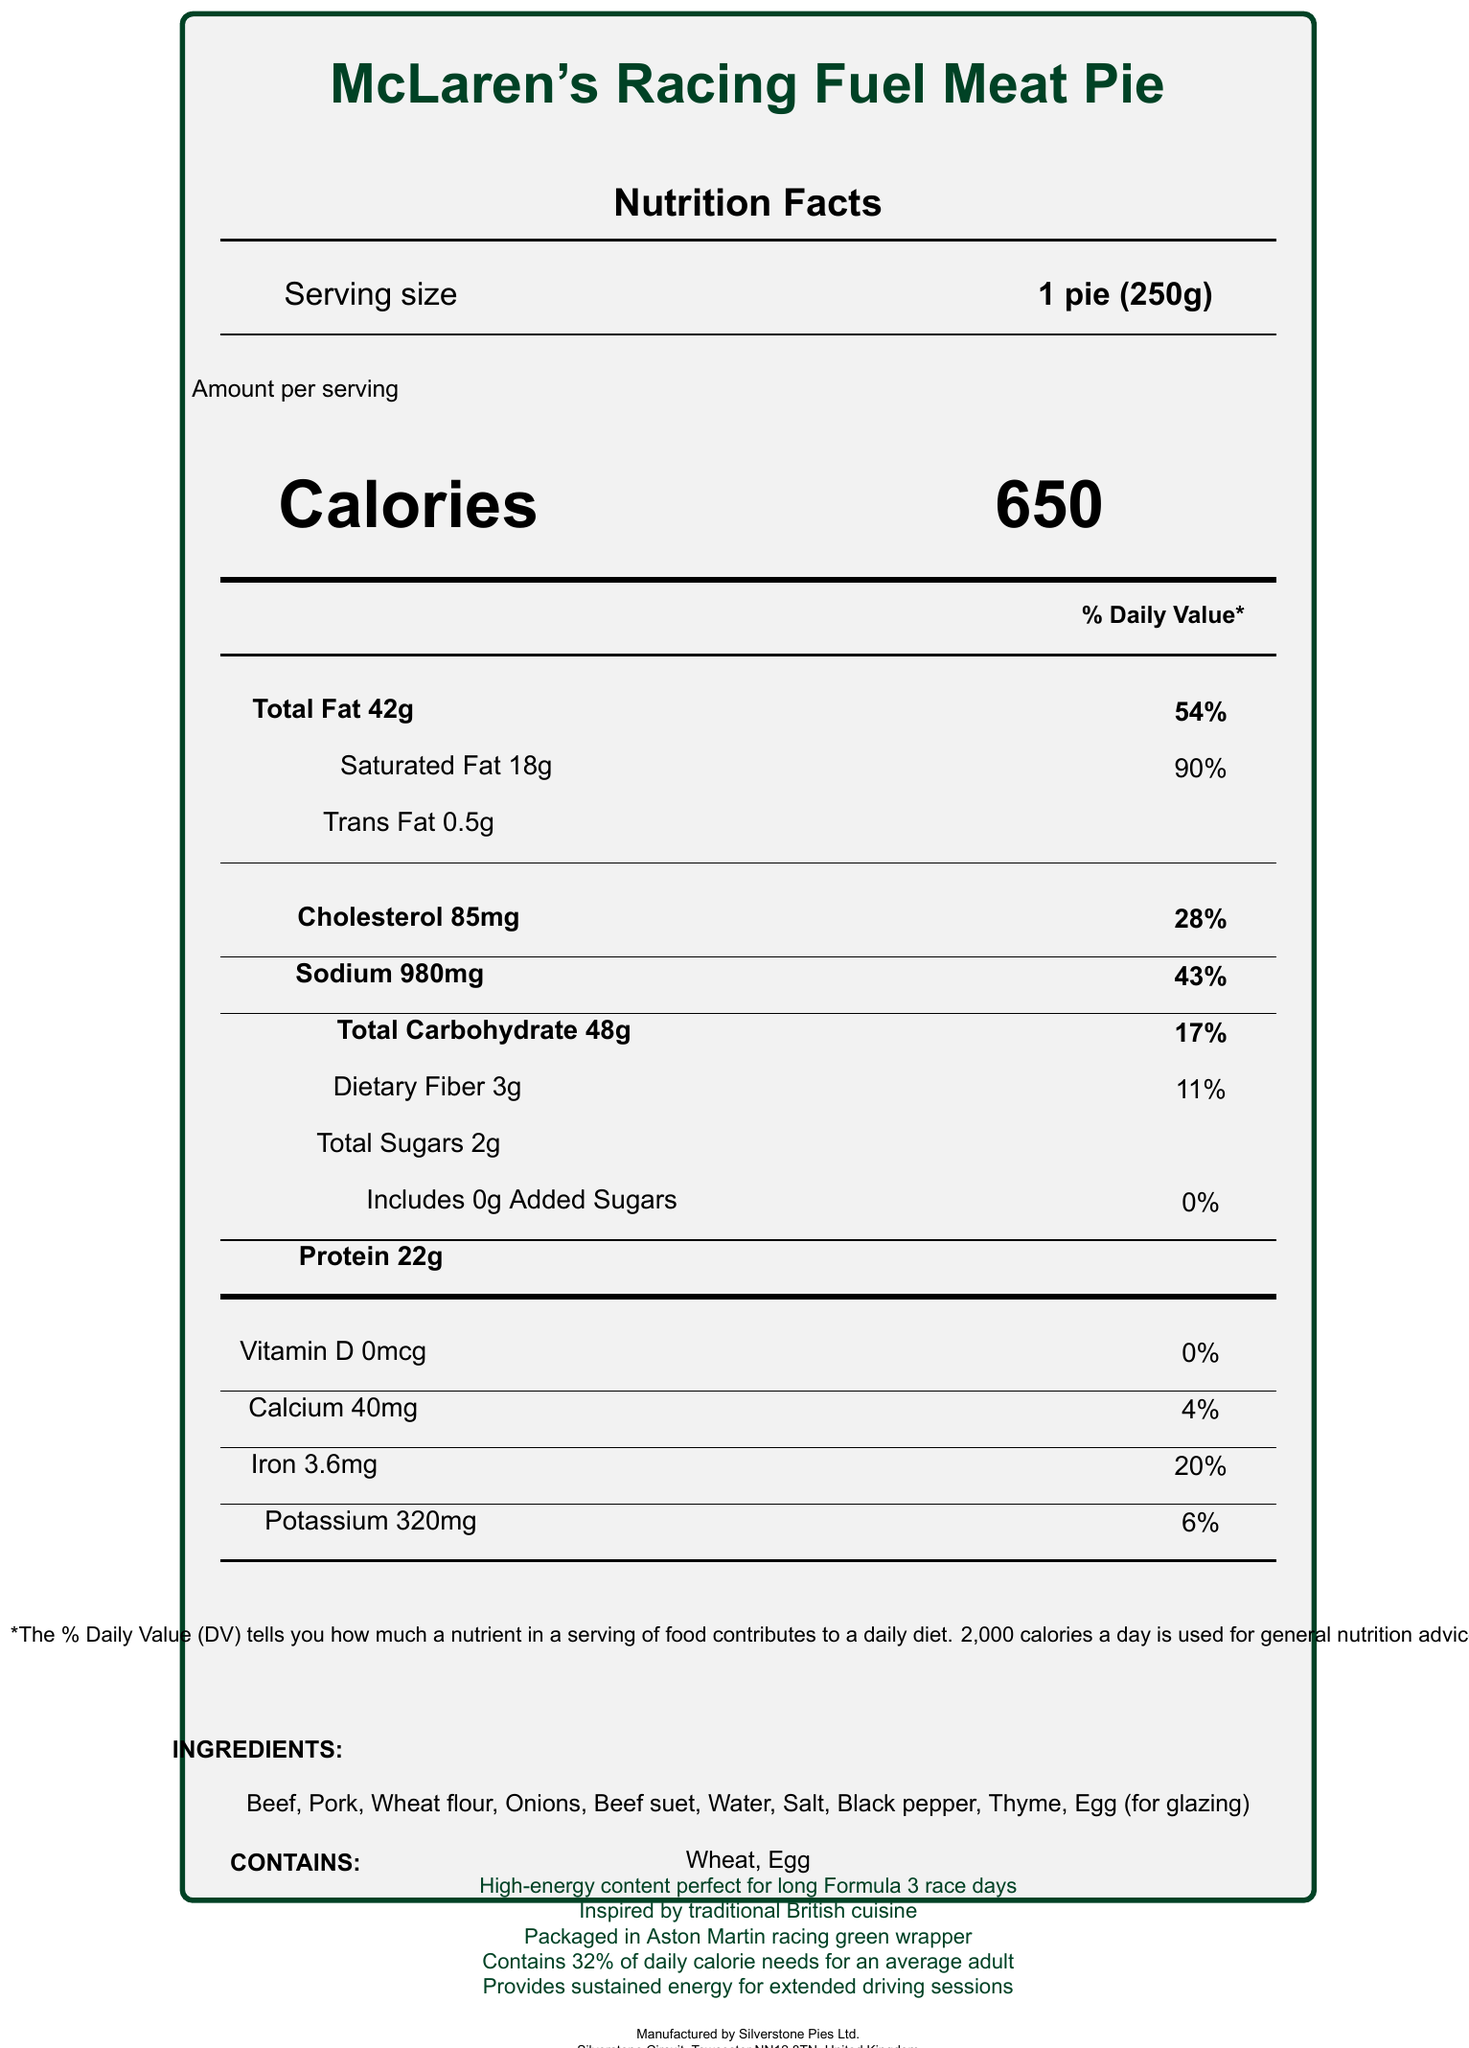what is the serving size for the McLaren's Racing Fuel Meat Pie? The serving size is listed at the top of the nutrition facts section as "1 pie (250g)".
Answer: 1 pie (250g) how many calories does one serving of the McLaren's Racing Fuel Meat Pie contain? The calories per serving are prominently displayed in the middle of the nutrition facts label.
Answer: 650 what percentage of the daily value of saturated fat is in one serving of the McLaren's Racing Fuel Meat Pie? The percentage of daily value for saturated fat is listed next to the saturated fat content.
Answer: 90% how much protein is in one serving of the McLaren's Racing Fuel Meat Pie? The protein content is listed at the bottom of the nutrition facts section.
Answer: 22g what is the total amount of dietary fiber in one serving? The dietary fiber content is listed under the total carbohydrate section.
Answer: 3g how much sodium is in one serving? A. 500mg B. 750mg C. 980mg D. 1000mg The amount of sodium is listed as 980mg next to the sodium section.
Answer: C which of the following is an ingredient in the McLaren's Racing Fuel Meat Pie? A. Chicken B. Beef C. Cheese D. Tomato The ingredients list includes beef but does not mention chicken, cheese, or tomato.
Answer: B does the McLaren's Racing Fuel Meat Pie contain any added sugars? The label states that the pie contains "Includes 0g Added Sugars" with a daily value of 0%.
Answer: No is the McLaren's Racing Fuel Meat Pie suitable for someone with a wheat allergy? The allergens list indicates that the pie contains wheat.
Answer: No summarize the main idea of the McLaren's Racing Fuel Meat Pie nutrition facts label. The label highlights key nutritional information for one serving of the meat pie, noting its high energy content and specific nutrient values. It emphasizes its suitability for long race days and extended driving sessions, lists ingredients and allergens, and mentions special packaging.
Answer: The McLaren's Racing Fuel Meat Pie provides a high-energy meal with 650 calories per serving, targeted towards car enthusiasts on long drives and Formula 3 race days. It includes 42g of total fat, 18g of saturated fat, 85mg of cholesterol, and 980mg of sodium. It also contains 22g of protein and various other nutrients. The pie contains allergens such as wheat and egg, and is packaged in a racing-themed wrapper. what is the address of the manufacturer, Silverstone Pies Ltd.? The manufacturer's address is listed at the bottom of the document in the small print section.
Answer: Silverstone Circuit, Towcester NN12 8TN, United Kingdom how much iron does one serving of the McLaren's Racing Fuel Meat Pie provide in terms of daily value? The percentage of daily value for iron is listed as 20% next to iron content.
Answer: 20% which British racing team inspired the packaging design of the McLaren's Racing Fuel Meat Pie? The special notes section mentions that the pie is packaged in an Aston Martin racing green wrapper.
Answer: Aston Martin how much potassium is in one serving? The amount of potassium is listed under the vitamins and minerals section.
Answer: 320mg does the McLaren's Racing Fuel Meat Pie contain any vitamin D? The label shows 0mcg of Vitamin D with a daily value of 0%.
Answer: No compare the daily value percentages of total fat and sodium. The daily value percentages for both total fat and sodium are listed next to their amounts in the nutrition facts.
Answer: Total fat has a daily value percentage of 54%, while sodium has a daily value percentage of 43%. what is unique about the packaging of the McLaren's Racing Fuel Meat Pie according to the special notes? The special notes state that the pie is packaged in an Aston Martin racing green wrapper.
Answer: It is packaged in Aston Martin racing green wrapper. how many servings are in one container of the McLaren's Racing Fuel Meat Pie? The label indicates that there is 1 serving per container.
Answer: 1 what is the exact amount of saturated fat in the McLaren's Racing Fuel Meat Pie? The exact amount of saturated fat is listed in the nutrition facts section.
Answer: 18g what percentage of the daily calorie needs for an average adult does one McLaren's Racing Fuel Meat Pie provide? The special notes mention that the pie contains 32% of daily calorie needs for an average adult.
Answer: 32% how much added sugars are in the McLaren's Racing Fuel Meat Pie? The nutrition facts state that there are 0g added sugars.
Answer: 0g who can answer more questions about the manufacturer's product lineup? The document does not provide specific contact details for customer inquiries beyond the website and general manufacturing info.
Answer: Not enough information 